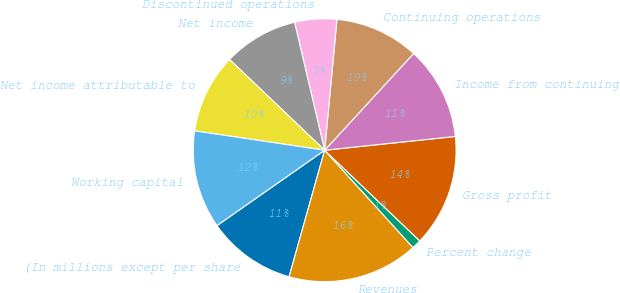<chart> <loc_0><loc_0><loc_500><loc_500><pie_chart><fcel>(In millions except per share<fcel>Revenues<fcel>Percent change<fcel>Gross profit<fcel>Income from continuing<fcel>Continuing operations<fcel>Discontinued operations<fcel>Net income<fcel>Net income attributable to<fcel>Working capital<nl><fcel>10.92%<fcel>16.09%<fcel>1.15%<fcel>13.79%<fcel>11.49%<fcel>10.34%<fcel>5.17%<fcel>9.2%<fcel>9.77%<fcel>12.07%<nl></chart> 